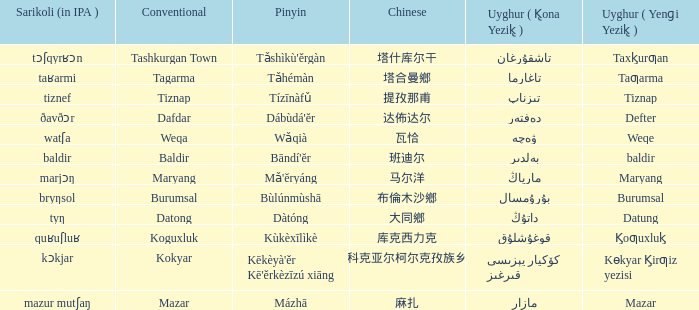Name the uyghur for  瓦恰 ۋەچە. 